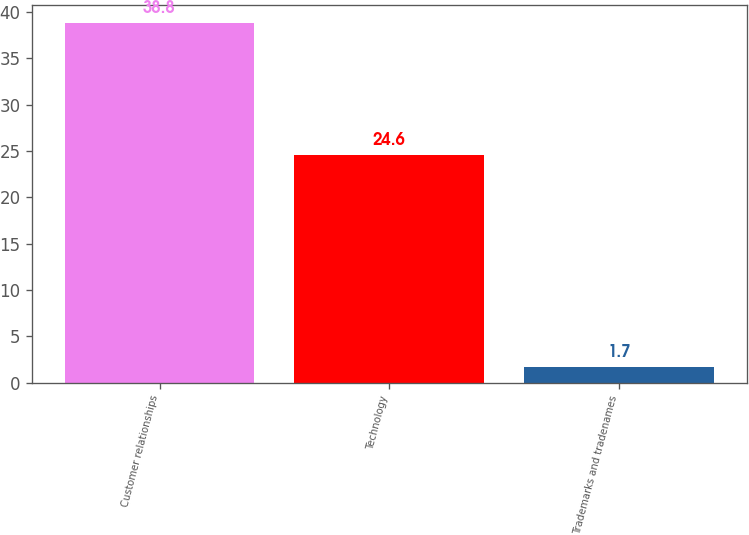<chart> <loc_0><loc_0><loc_500><loc_500><bar_chart><fcel>Customer relationships<fcel>Technology<fcel>Trademarks and tradenames<nl><fcel>38.8<fcel>24.6<fcel>1.7<nl></chart> 